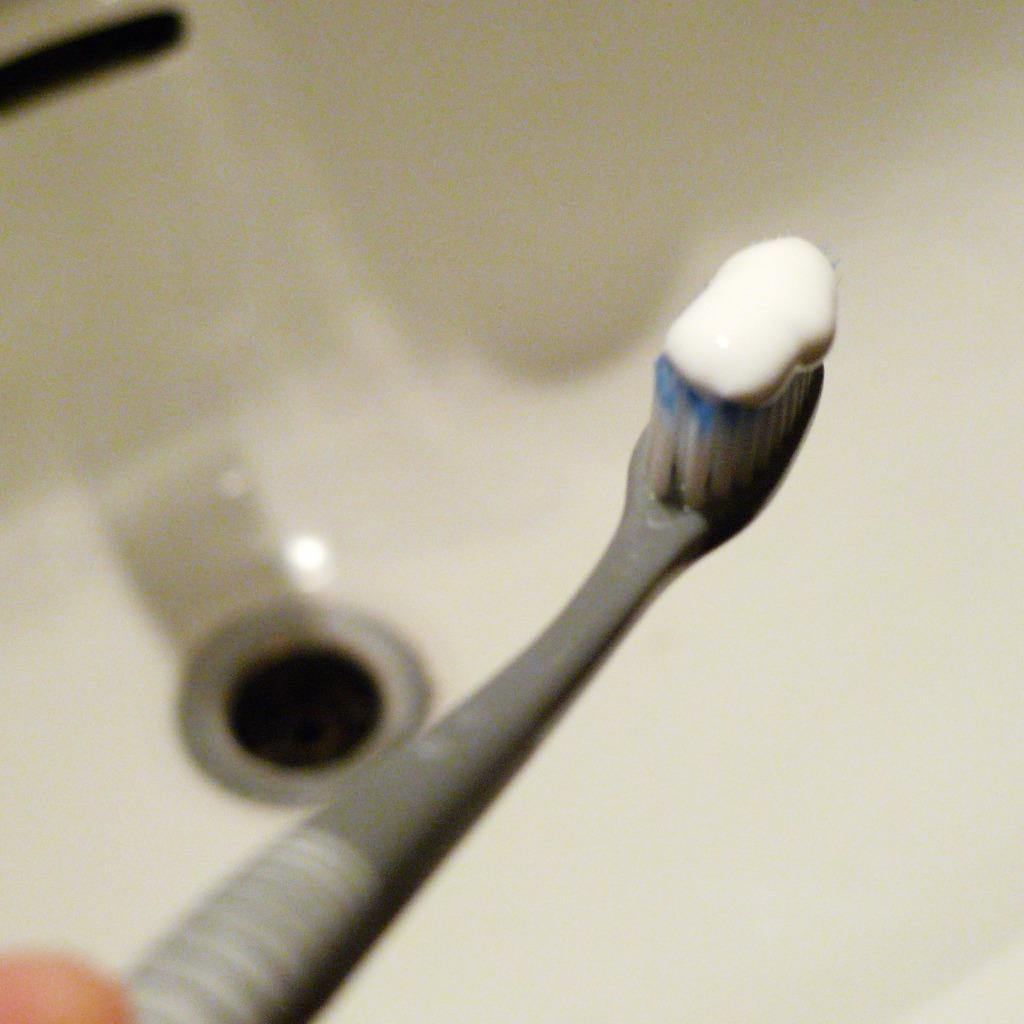Could you give a brief overview of what you see in this image? In this picture we can see a toothbrush with toothpaste on it. In the background, we can see a white sink with a sinkhole. 